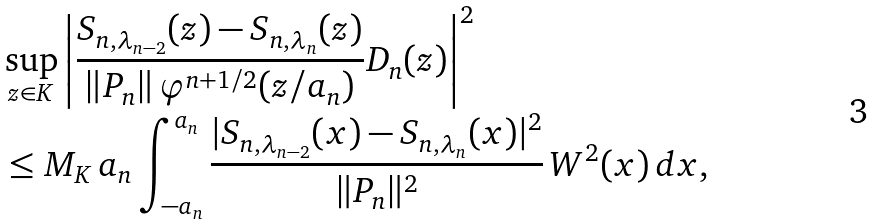<formula> <loc_0><loc_0><loc_500><loc_500>& \sup _ { z \in K } \left | \frac { S _ { n , \lambda _ { n - 2 } } ( z ) - S _ { n , \lambda _ { n } } ( z ) } { \| P _ { n } \| \, \varphi ^ { n + 1 / 2 } ( z / a _ { n } ) } D _ { n } ( z ) \right | ^ { 2 } \\ & \leq M _ { K } \, a _ { n } \int _ { - a _ { n } } ^ { a _ { n } } \frac { | S _ { n , \lambda _ { n - 2 } } ( x ) - S _ { n , \lambda _ { n } } ( x ) | ^ { 2 } } { \| P _ { n } \| ^ { 2 } } \, W ^ { 2 } ( x ) \, d x ,</formula> 